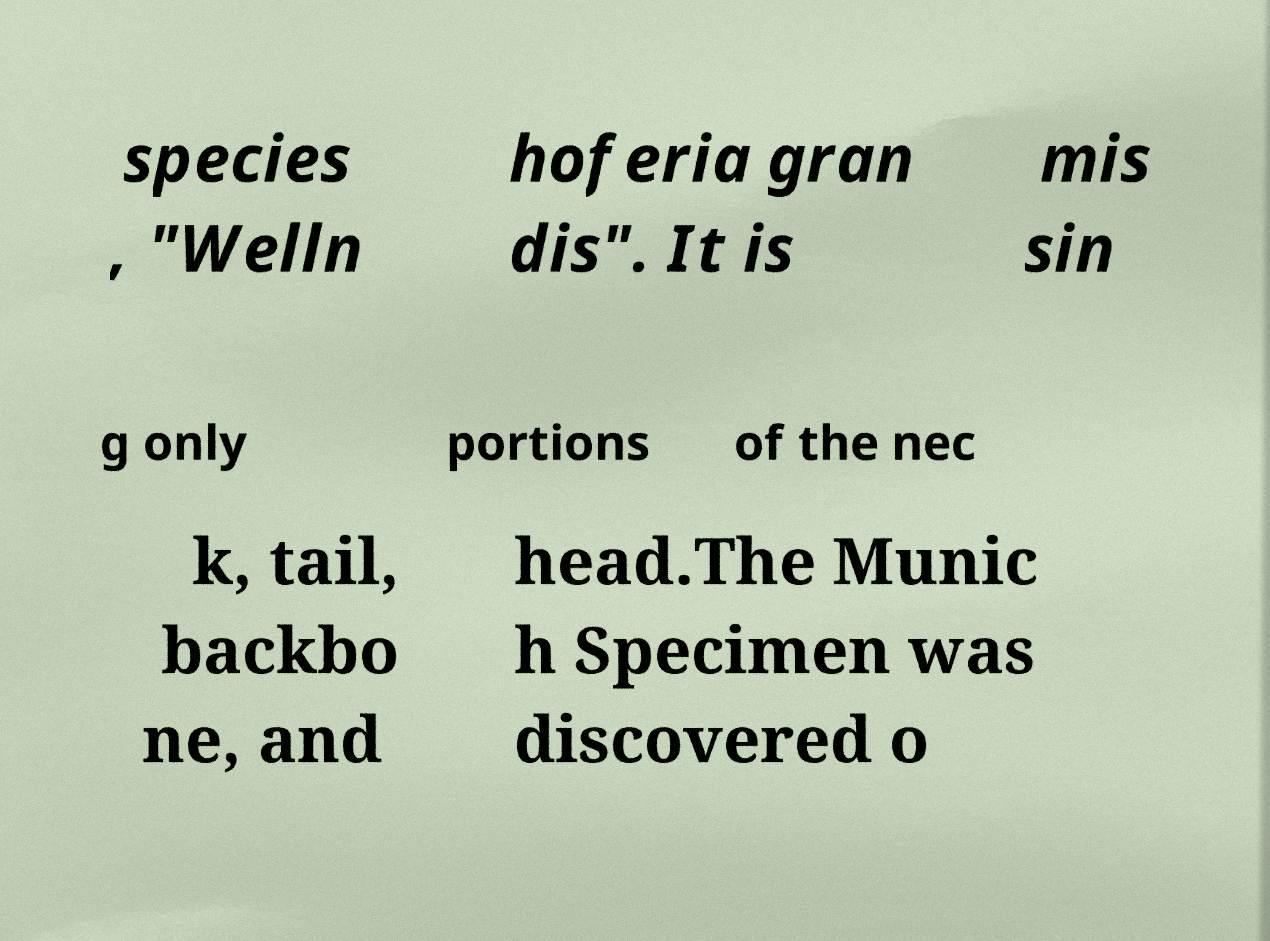Could you assist in decoding the text presented in this image and type it out clearly? species , "Welln hoferia gran dis". It is mis sin g only portions of the nec k, tail, backbo ne, and head.The Munic h Specimen was discovered o 